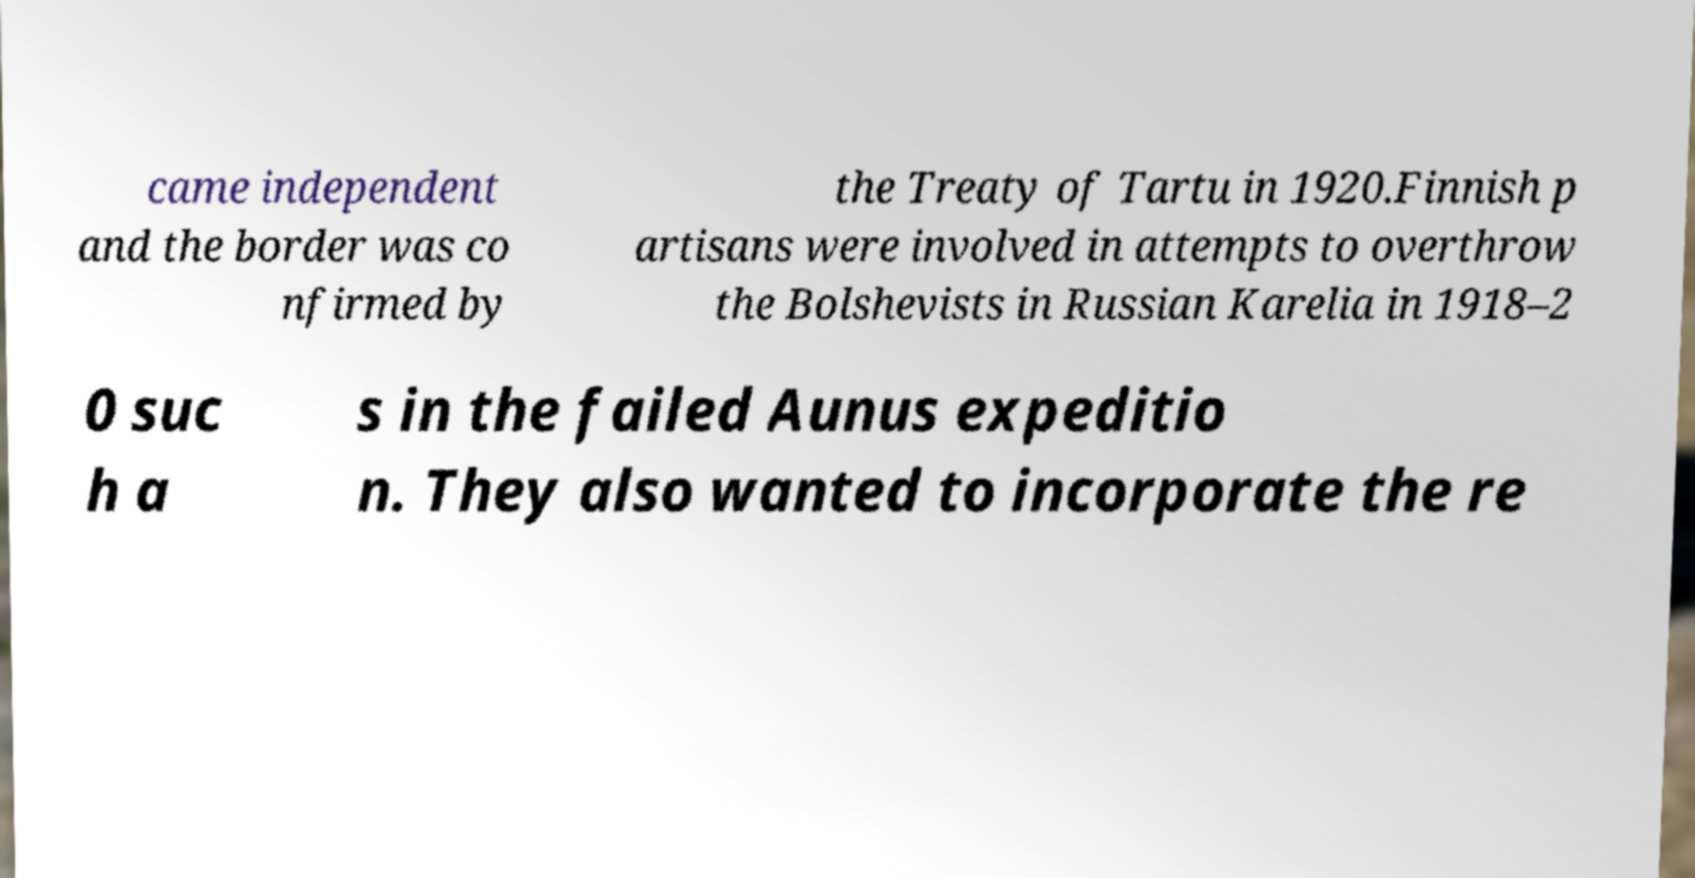Please identify and transcribe the text found in this image. came independent and the border was co nfirmed by the Treaty of Tartu in 1920.Finnish p artisans were involved in attempts to overthrow the Bolshevists in Russian Karelia in 1918–2 0 suc h a s in the failed Aunus expeditio n. They also wanted to incorporate the re 